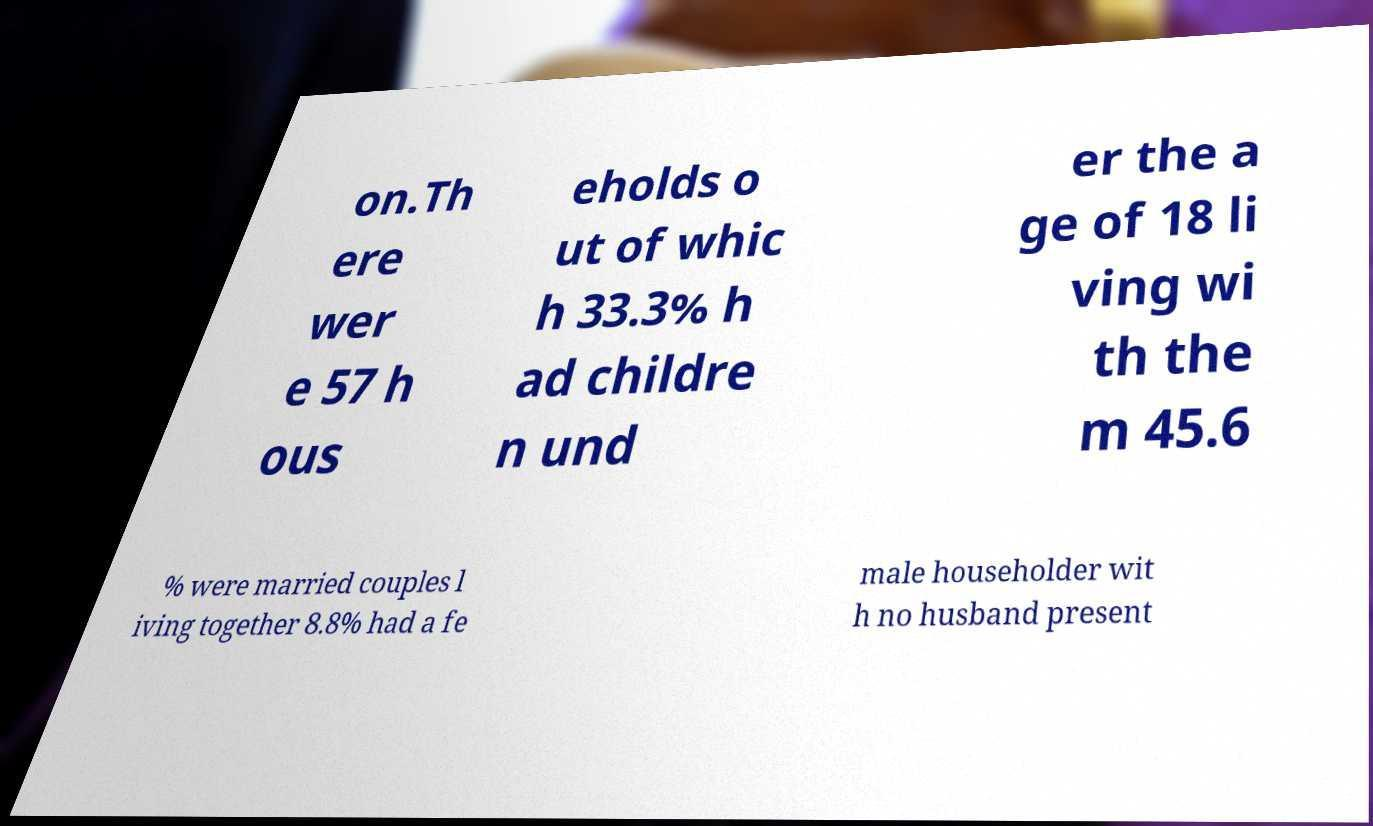For documentation purposes, I need the text within this image transcribed. Could you provide that? on.Th ere wer e 57 h ous eholds o ut of whic h 33.3% h ad childre n und er the a ge of 18 li ving wi th the m 45.6 % were married couples l iving together 8.8% had a fe male householder wit h no husband present 